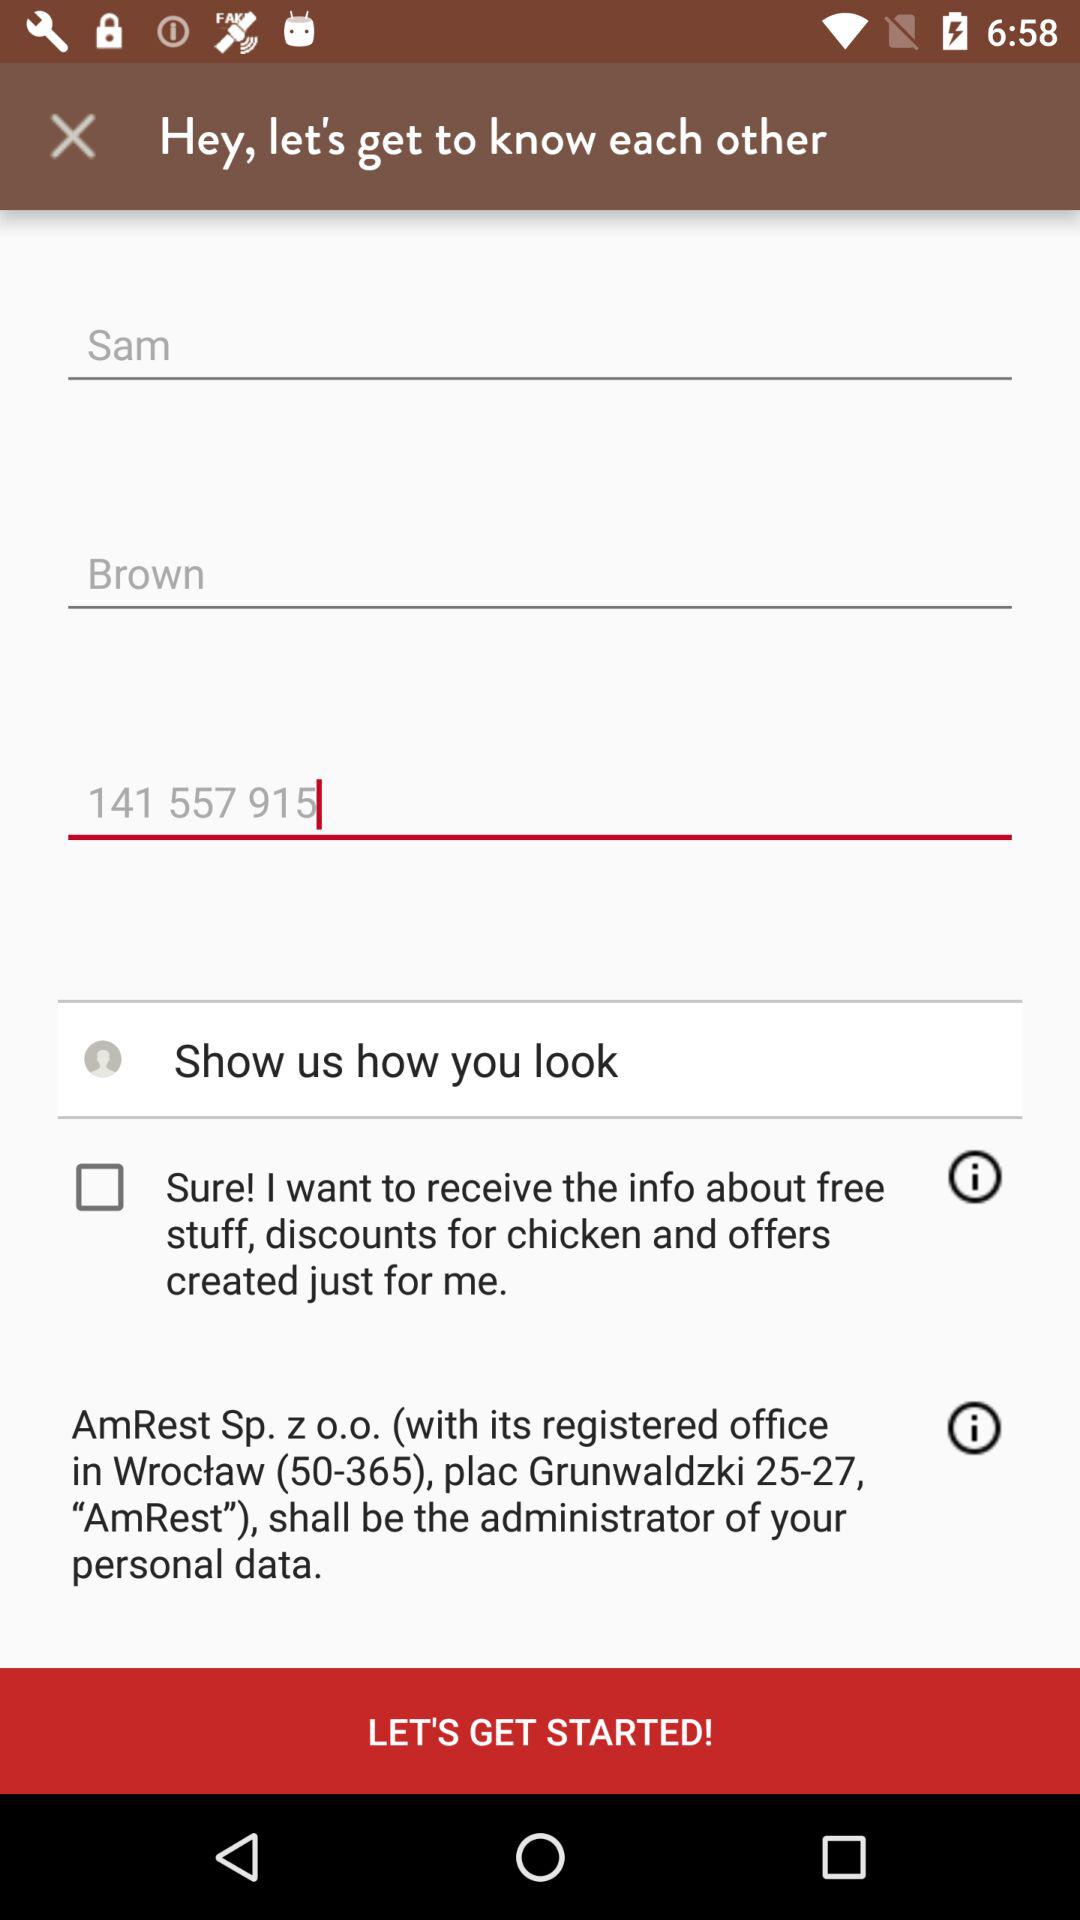What is the status of "Sure! I want to receive the info about free stuff, discounts for chicken and offers created just for me"? The status is "off". 